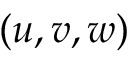<formula> <loc_0><loc_0><loc_500><loc_500>( u , v , w )</formula> 